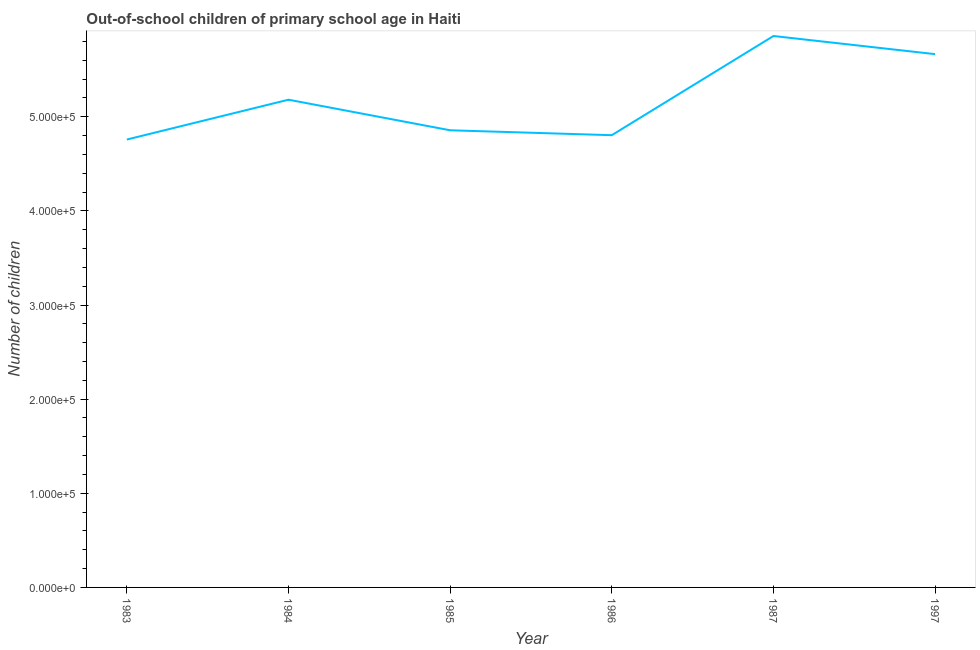What is the number of out-of-school children in 1997?
Give a very brief answer. 5.67e+05. Across all years, what is the maximum number of out-of-school children?
Offer a very short reply. 5.86e+05. Across all years, what is the minimum number of out-of-school children?
Make the answer very short. 4.76e+05. In which year was the number of out-of-school children minimum?
Offer a terse response. 1983. What is the sum of the number of out-of-school children?
Offer a very short reply. 3.11e+06. What is the difference between the number of out-of-school children in 1983 and 1985?
Your response must be concise. -9827. What is the average number of out-of-school children per year?
Provide a short and direct response. 5.19e+05. What is the median number of out-of-school children?
Offer a very short reply. 5.02e+05. What is the ratio of the number of out-of-school children in 1983 to that in 1987?
Your answer should be very brief. 0.81. Is the number of out-of-school children in 1984 less than that in 1985?
Make the answer very short. No. What is the difference between the highest and the second highest number of out-of-school children?
Keep it short and to the point. 1.93e+04. Is the sum of the number of out-of-school children in 1983 and 1986 greater than the maximum number of out-of-school children across all years?
Give a very brief answer. Yes. What is the difference between the highest and the lowest number of out-of-school children?
Provide a succinct answer. 1.10e+05. How many lines are there?
Offer a very short reply. 1. What is the difference between two consecutive major ticks on the Y-axis?
Keep it short and to the point. 1.00e+05. Are the values on the major ticks of Y-axis written in scientific E-notation?
Your response must be concise. Yes. What is the title of the graph?
Offer a terse response. Out-of-school children of primary school age in Haiti. What is the label or title of the X-axis?
Offer a terse response. Year. What is the label or title of the Y-axis?
Your response must be concise. Number of children. What is the Number of children of 1983?
Provide a succinct answer. 4.76e+05. What is the Number of children of 1984?
Make the answer very short. 5.18e+05. What is the Number of children of 1985?
Your answer should be very brief. 4.86e+05. What is the Number of children of 1986?
Your answer should be compact. 4.80e+05. What is the Number of children in 1987?
Keep it short and to the point. 5.86e+05. What is the Number of children in 1997?
Your answer should be compact. 5.67e+05. What is the difference between the Number of children in 1983 and 1984?
Your answer should be compact. -4.23e+04. What is the difference between the Number of children in 1983 and 1985?
Provide a succinct answer. -9827. What is the difference between the Number of children in 1983 and 1986?
Ensure brevity in your answer.  -4612. What is the difference between the Number of children in 1983 and 1987?
Make the answer very short. -1.10e+05. What is the difference between the Number of children in 1983 and 1997?
Offer a very short reply. -9.07e+04. What is the difference between the Number of children in 1984 and 1985?
Give a very brief answer. 3.25e+04. What is the difference between the Number of children in 1984 and 1986?
Offer a very short reply. 3.77e+04. What is the difference between the Number of children in 1984 and 1987?
Make the answer very short. -6.77e+04. What is the difference between the Number of children in 1984 and 1997?
Provide a succinct answer. -4.84e+04. What is the difference between the Number of children in 1985 and 1986?
Your answer should be compact. 5215. What is the difference between the Number of children in 1985 and 1987?
Your answer should be very brief. -1.00e+05. What is the difference between the Number of children in 1985 and 1997?
Offer a very short reply. -8.09e+04. What is the difference between the Number of children in 1986 and 1987?
Provide a short and direct response. -1.05e+05. What is the difference between the Number of children in 1986 and 1997?
Give a very brief answer. -8.61e+04. What is the difference between the Number of children in 1987 and 1997?
Provide a short and direct response. 1.93e+04. What is the ratio of the Number of children in 1983 to that in 1984?
Ensure brevity in your answer.  0.92. What is the ratio of the Number of children in 1983 to that in 1986?
Keep it short and to the point. 0.99. What is the ratio of the Number of children in 1983 to that in 1987?
Give a very brief answer. 0.81. What is the ratio of the Number of children in 1983 to that in 1997?
Provide a succinct answer. 0.84. What is the ratio of the Number of children in 1984 to that in 1985?
Keep it short and to the point. 1.07. What is the ratio of the Number of children in 1984 to that in 1986?
Offer a terse response. 1.08. What is the ratio of the Number of children in 1984 to that in 1987?
Your answer should be very brief. 0.88. What is the ratio of the Number of children in 1984 to that in 1997?
Give a very brief answer. 0.92. What is the ratio of the Number of children in 1985 to that in 1986?
Make the answer very short. 1.01. What is the ratio of the Number of children in 1985 to that in 1987?
Make the answer very short. 0.83. What is the ratio of the Number of children in 1985 to that in 1997?
Give a very brief answer. 0.86. What is the ratio of the Number of children in 1986 to that in 1987?
Ensure brevity in your answer.  0.82. What is the ratio of the Number of children in 1986 to that in 1997?
Provide a short and direct response. 0.85. What is the ratio of the Number of children in 1987 to that in 1997?
Provide a succinct answer. 1.03. 